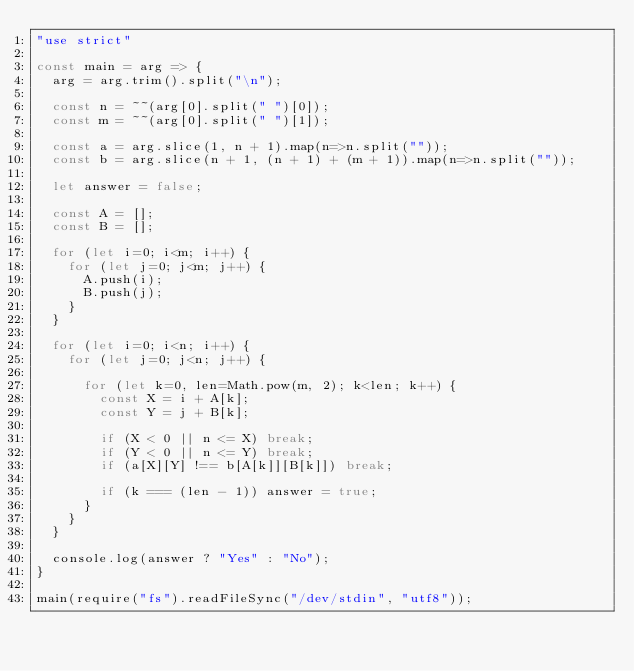Convert code to text. <code><loc_0><loc_0><loc_500><loc_500><_JavaScript_>"use strict"

const main = arg => {
  arg = arg.trim().split("\n");

  const n = ~~(arg[0].split(" ")[0]);
  const m = ~~(arg[0].split(" ")[1]);

  const a = arg.slice(1, n + 1).map(n=>n.split(""));
  const b = arg.slice(n + 1, (n + 1) + (m + 1)).map(n=>n.split(""));

  let answer = false;

  const A = [];
  const B = [];

  for (let i=0; i<m; i++) {
    for (let j=0; j<m; j++) {
      A.push(i);
      B.push(j);
    }
  }
  
  for (let i=0; i<n; i++) {
    for (let j=0; j<n; j++) {
      
      for (let k=0, len=Math.pow(m, 2); k<len; k++) {
        const X = i + A[k];
        const Y = j + B[k];
        
        if (X < 0 || n <= X) break;
        if (Y < 0 || n <= Y) break;
        if (a[X][Y] !== b[A[k]][B[k]]) break;

        if (k === (len - 1)) answer = true;
      }
    }
  }

  console.log(answer ? "Yes" : "No");
}

main(require("fs").readFileSync("/dev/stdin", "utf8"));</code> 